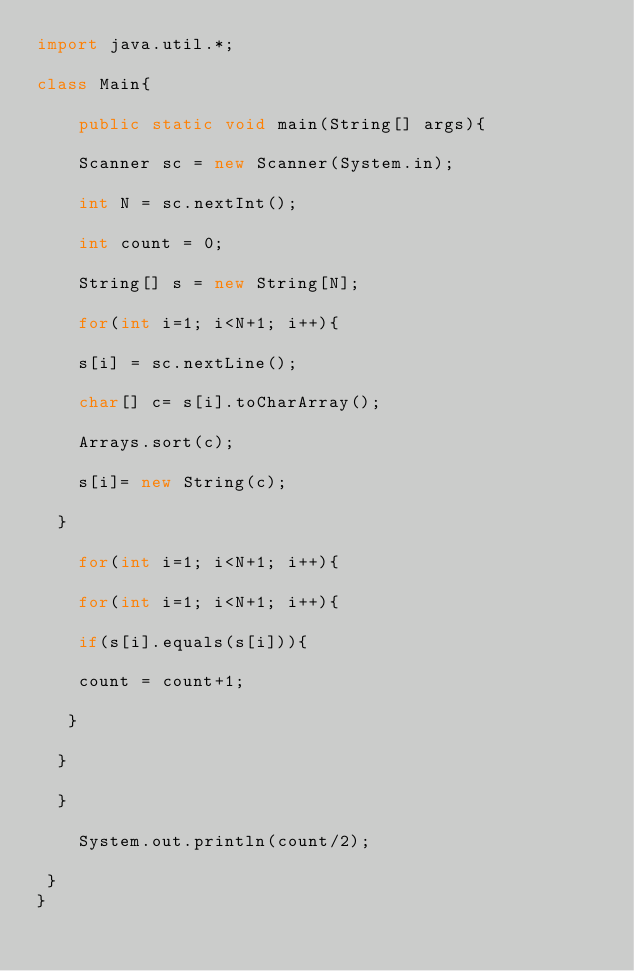Convert code to text. <code><loc_0><loc_0><loc_500><loc_500><_Java_>import java.util.*;

class Main{

    public static void main(String[] args){

	Scanner sc = new Scanner(System.in);

	int N = sc.nextInt();

	int count = 0;

	String[] s = new String[N]; 

	for(int i=1; i<N+1; i++){

	s[i] = sc.nextLine();

	char[] c= s[i].toCharArray();

	Arrays.sort(c);

	s[i]= new String(c);
	
  }

	for(int i=1; i<N+1; i++){

	for(int i=1; i<N+1; i++){
	
	if(s[i].equals(s[i])){

	count = count+1;	

   }	
		
  }	

  }			

	System.out.println(count/2);
	  
 }
}</code> 